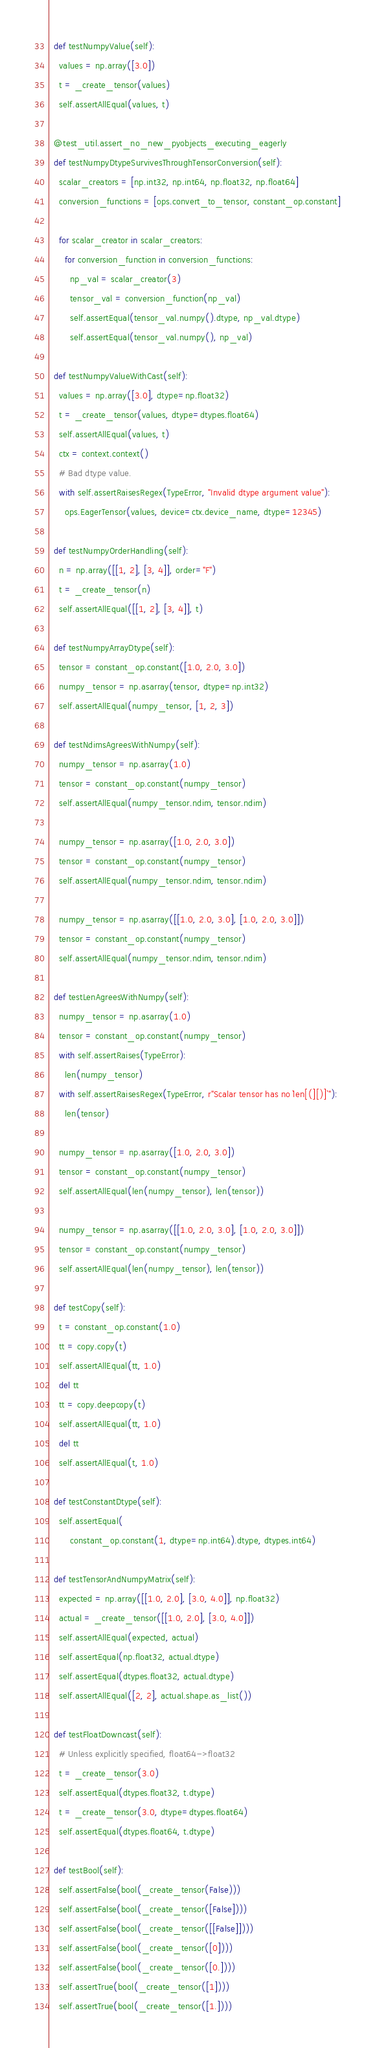Convert code to text. <code><loc_0><loc_0><loc_500><loc_500><_Python_>
  def testNumpyValue(self):
    values = np.array([3.0])
    t = _create_tensor(values)
    self.assertAllEqual(values, t)

  @test_util.assert_no_new_pyobjects_executing_eagerly
  def testNumpyDtypeSurvivesThroughTensorConversion(self):
    scalar_creators = [np.int32, np.int64, np.float32, np.float64]
    conversion_functions = [ops.convert_to_tensor, constant_op.constant]

    for scalar_creator in scalar_creators:
      for conversion_function in conversion_functions:
        np_val = scalar_creator(3)
        tensor_val = conversion_function(np_val)
        self.assertEqual(tensor_val.numpy().dtype, np_val.dtype)
        self.assertEqual(tensor_val.numpy(), np_val)

  def testNumpyValueWithCast(self):
    values = np.array([3.0], dtype=np.float32)
    t = _create_tensor(values, dtype=dtypes.float64)
    self.assertAllEqual(values, t)
    ctx = context.context()
    # Bad dtype value.
    with self.assertRaisesRegex(TypeError, "Invalid dtype argument value"):
      ops.EagerTensor(values, device=ctx.device_name, dtype=12345)

  def testNumpyOrderHandling(self):
    n = np.array([[1, 2], [3, 4]], order="F")
    t = _create_tensor(n)
    self.assertAllEqual([[1, 2], [3, 4]], t)

  def testNumpyArrayDtype(self):
    tensor = constant_op.constant([1.0, 2.0, 3.0])
    numpy_tensor = np.asarray(tensor, dtype=np.int32)
    self.assertAllEqual(numpy_tensor, [1, 2, 3])

  def testNdimsAgreesWithNumpy(self):
    numpy_tensor = np.asarray(1.0)
    tensor = constant_op.constant(numpy_tensor)
    self.assertAllEqual(numpy_tensor.ndim, tensor.ndim)

    numpy_tensor = np.asarray([1.0, 2.0, 3.0])
    tensor = constant_op.constant(numpy_tensor)
    self.assertAllEqual(numpy_tensor.ndim, tensor.ndim)

    numpy_tensor = np.asarray([[1.0, 2.0, 3.0], [1.0, 2.0, 3.0]])
    tensor = constant_op.constant(numpy_tensor)
    self.assertAllEqual(numpy_tensor.ndim, tensor.ndim)

  def testLenAgreesWithNumpy(self):
    numpy_tensor = np.asarray(1.0)
    tensor = constant_op.constant(numpy_tensor)
    with self.assertRaises(TypeError):
      len(numpy_tensor)
    with self.assertRaisesRegex(TypeError, r"Scalar tensor has no `len[(][)]`"):
      len(tensor)

    numpy_tensor = np.asarray([1.0, 2.0, 3.0])
    tensor = constant_op.constant(numpy_tensor)
    self.assertAllEqual(len(numpy_tensor), len(tensor))

    numpy_tensor = np.asarray([[1.0, 2.0, 3.0], [1.0, 2.0, 3.0]])
    tensor = constant_op.constant(numpy_tensor)
    self.assertAllEqual(len(numpy_tensor), len(tensor))

  def testCopy(self):
    t = constant_op.constant(1.0)
    tt = copy.copy(t)
    self.assertAllEqual(tt, 1.0)
    del tt
    tt = copy.deepcopy(t)
    self.assertAllEqual(tt, 1.0)
    del tt
    self.assertAllEqual(t, 1.0)

  def testConstantDtype(self):
    self.assertEqual(
        constant_op.constant(1, dtype=np.int64).dtype, dtypes.int64)

  def testTensorAndNumpyMatrix(self):
    expected = np.array([[1.0, 2.0], [3.0, 4.0]], np.float32)
    actual = _create_tensor([[1.0, 2.0], [3.0, 4.0]])
    self.assertAllEqual(expected, actual)
    self.assertEqual(np.float32, actual.dtype)
    self.assertEqual(dtypes.float32, actual.dtype)
    self.assertAllEqual([2, 2], actual.shape.as_list())

  def testFloatDowncast(self):
    # Unless explicitly specified, float64->float32
    t = _create_tensor(3.0)
    self.assertEqual(dtypes.float32, t.dtype)
    t = _create_tensor(3.0, dtype=dtypes.float64)
    self.assertEqual(dtypes.float64, t.dtype)

  def testBool(self):
    self.assertFalse(bool(_create_tensor(False)))
    self.assertFalse(bool(_create_tensor([False])))
    self.assertFalse(bool(_create_tensor([[False]])))
    self.assertFalse(bool(_create_tensor([0])))
    self.assertFalse(bool(_create_tensor([0.])))
    self.assertTrue(bool(_create_tensor([1])))
    self.assertTrue(bool(_create_tensor([1.])))
</code> 